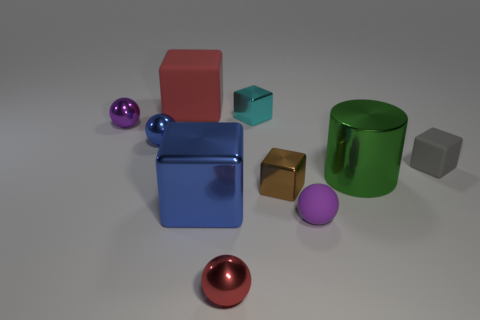Subtract all large blocks. How many blocks are left? 3 Subtract 2 balls. How many balls are left? 2 Subtract all blue spheres. How many spheres are left? 3 Subtract all green cubes. Subtract all blue cylinders. How many cubes are left? 5 Subtract all cylinders. How many objects are left? 9 Subtract 0 cyan cylinders. How many objects are left? 10 Subtract all small red things. Subtract all small gray cubes. How many objects are left? 8 Add 9 purple metallic spheres. How many purple metallic spheres are left? 10 Add 9 brown things. How many brown things exist? 10 